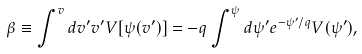Convert formula to latex. <formula><loc_0><loc_0><loc_500><loc_500>\beta \equiv \int ^ { v } d v ^ { \prime } v ^ { \prime } V [ \psi ( v ^ { \prime } ) ] = - q \int ^ { \psi } d \psi ^ { \prime } e ^ { - \psi ^ { \prime } / q } V ( \psi ^ { \prime } ) ,</formula> 